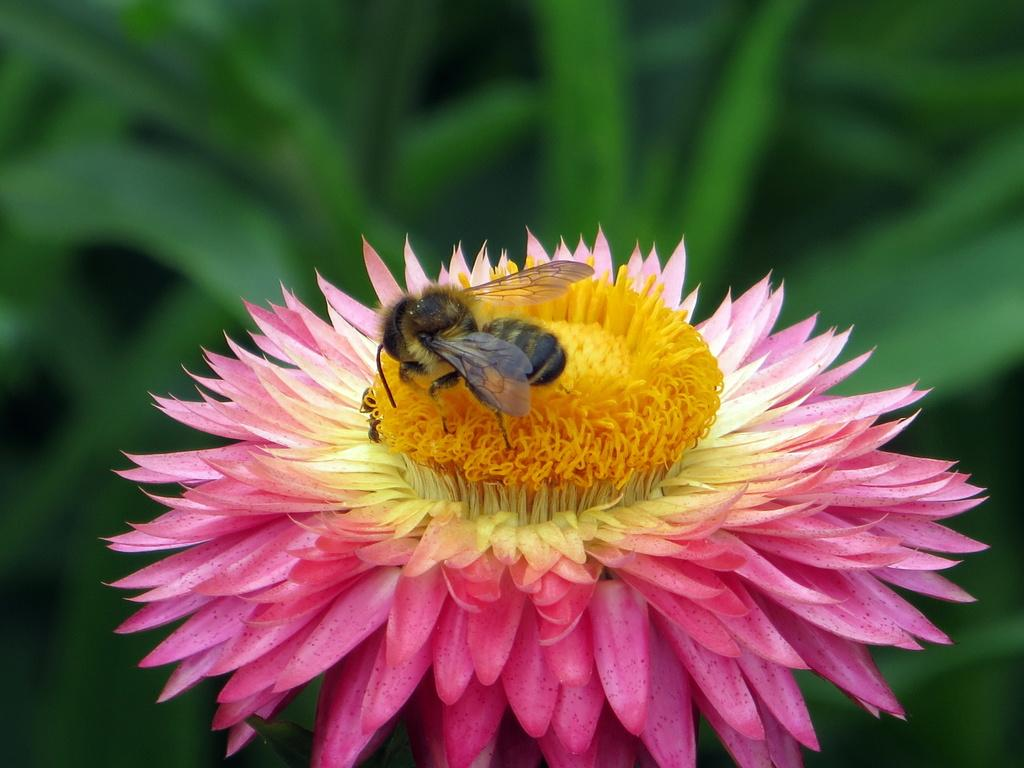What colors are present in the flower in the image? The flower in the image has pink, yellow, and cream colors. What else can be seen on the flower in the image? An insect is present on the flower in the image. What color is the background of the image? The background of the image is green. What type of mouth can be seen on the flower in the image? There is no mouth present on the flower in the image, as flowers do not have mouths. 